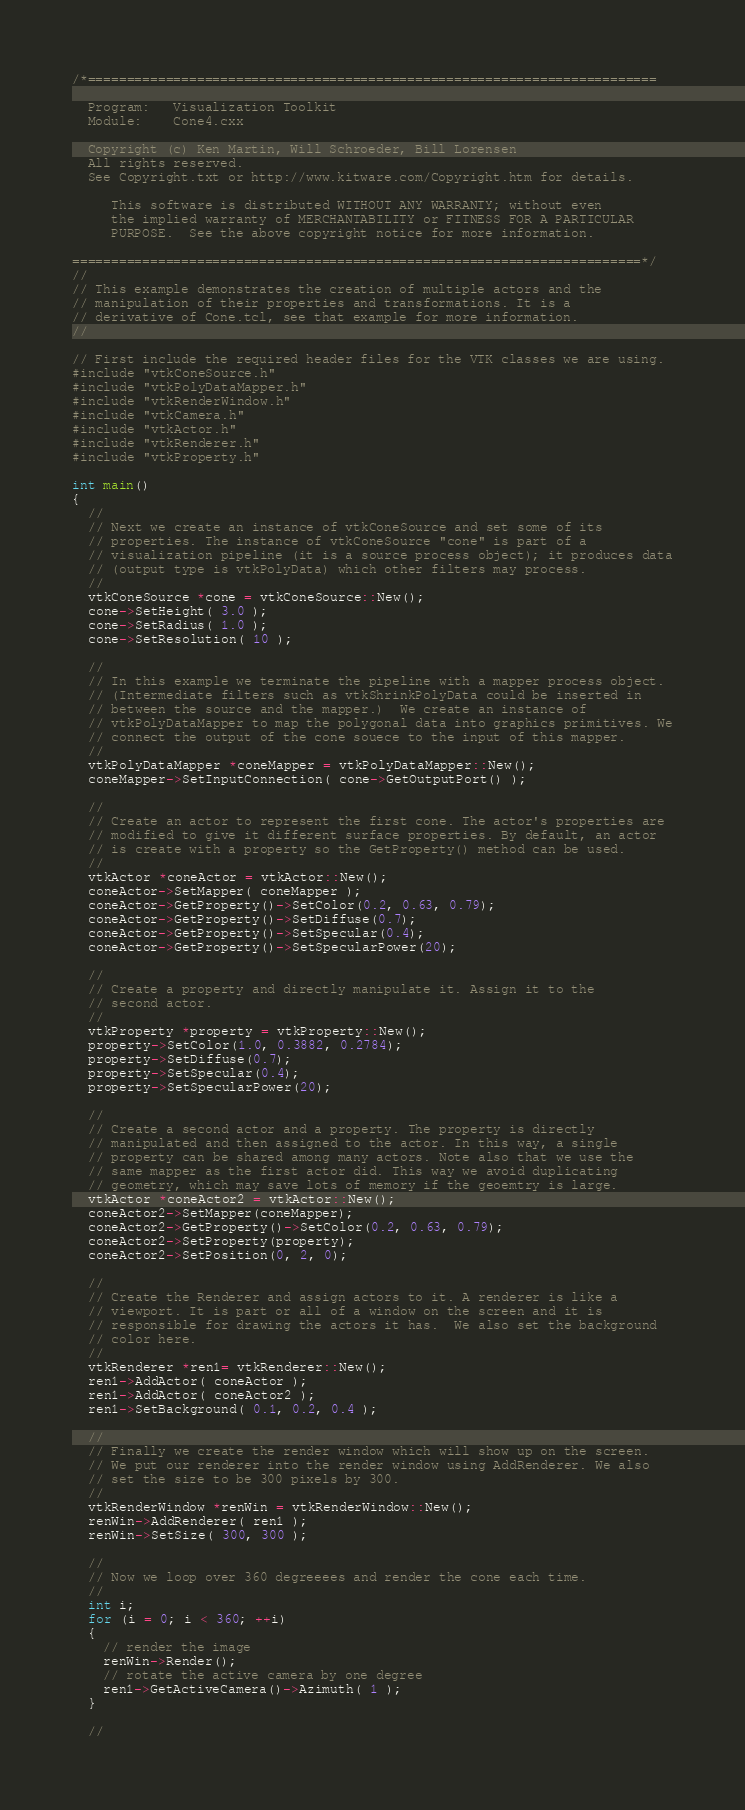Convert code to text. <code><loc_0><loc_0><loc_500><loc_500><_C++_>/*=========================================================================

  Program:   Visualization Toolkit
  Module:    Cone4.cxx

  Copyright (c) Ken Martin, Will Schroeder, Bill Lorensen
  All rights reserved.
  See Copyright.txt or http://www.kitware.com/Copyright.htm for details.

     This software is distributed WITHOUT ANY WARRANTY; without even
     the implied warranty of MERCHANTABILITY or FITNESS FOR A PARTICULAR
     PURPOSE.  See the above copyright notice for more information.

=========================================================================*/
//
// This example demonstrates the creation of multiple actors and the
// manipulation of their properties and transformations. It is a
// derivative of Cone.tcl, see that example for more information.
//

// First include the required header files for the VTK classes we are using.
#include "vtkConeSource.h"
#include "vtkPolyDataMapper.h"
#include "vtkRenderWindow.h"
#include "vtkCamera.h"
#include "vtkActor.h"
#include "vtkRenderer.h"
#include "vtkProperty.h"

int main()
{
  //
  // Next we create an instance of vtkConeSource and set some of its
  // properties. The instance of vtkConeSource "cone" is part of a
  // visualization pipeline (it is a source process object); it produces data
  // (output type is vtkPolyData) which other filters may process.
  //
  vtkConeSource *cone = vtkConeSource::New();
  cone->SetHeight( 3.0 );
  cone->SetRadius( 1.0 );
  cone->SetResolution( 10 );

  //
  // In this example we terminate the pipeline with a mapper process object.
  // (Intermediate filters such as vtkShrinkPolyData could be inserted in
  // between the source and the mapper.)  We create an instance of
  // vtkPolyDataMapper to map the polygonal data into graphics primitives. We
  // connect the output of the cone souece to the input of this mapper.
  //
  vtkPolyDataMapper *coneMapper = vtkPolyDataMapper::New();
  coneMapper->SetInputConnection( cone->GetOutputPort() );

  //
  // Create an actor to represent the first cone. The actor's properties are
  // modified to give it different surface properties. By default, an actor
  // is create with a property so the GetProperty() method can be used.
  //
  vtkActor *coneActor = vtkActor::New();
  coneActor->SetMapper( coneMapper );
  coneActor->GetProperty()->SetColor(0.2, 0.63, 0.79);
  coneActor->GetProperty()->SetDiffuse(0.7);
  coneActor->GetProperty()->SetSpecular(0.4);
  coneActor->GetProperty()->SetSpecularPower(20);

  //
  // Create a property and directly manipulate it. Assign it to the
  // second actor.
  //
  vtkProperty *property = vtkProperty::New();
  property->SetColor(1.0, 0.3882, 0.2784);
  property->SetDiffuse(0.7);
  property->SetSpecular(0.4);
  property->SetSpecularPower(20);

  //
  // Create a second actor and a property. The property is directly
  // manipulated and then assigned to the actor. In this way, a single
  // property can be shared among many actors. Note also that we use the
  // same mapper as the first actor did. This way we avoid duplicating
  // geometry, which may save lots of memory if the geoemtry is large.
  vtkActor *coneActor2 = vtkActor::New();
  coneActor2->SetMapper(coneMapper);
  coneActor2->GetProperty()->SetColor(0.2, 0.63, 0.79);
  coneActor2->SetProperty(property);
  coneActor2->SetPosition(0, 2, 0);

  //
  // Create the Renderer and assign actors to it. A renderer is like a
  // viewport. It is part or all of a window on the screen and it is
  // responsible for drawing the actors it has.  We also set the background
  // color here.
  //
  vtkRenderer *ren1= vtkRenderer::New();
  ren1->AddActor( coneActor );
  ren1->AddActor( coneActor2 );
  ren1->SetBackground( 0.1, 0.2, 0.4 );

  //
  // Finally we create the render window which will show up on the screen.
  // We put our renderer into the render window using AddRenderer. We also
  // set the size to be 300 pixels by 300.
  //
  vtkRenderWindow *renWin = vtkRenderWindow::New();
  renWin->AddRenderer( ren1 );
  renWin->SetSize( 300, 300 );

  //
  // Now we loop over 360 degreeees and render the cone each time.
  //
  int i;
  for (i = 0; i < 360; ++i)
  {
    // render the image
    renWin->Render();
    // rotate the active camera by one degree
    ren1->GetActiveCamera()->Azimuth( 1 );
  }

  //</code> 